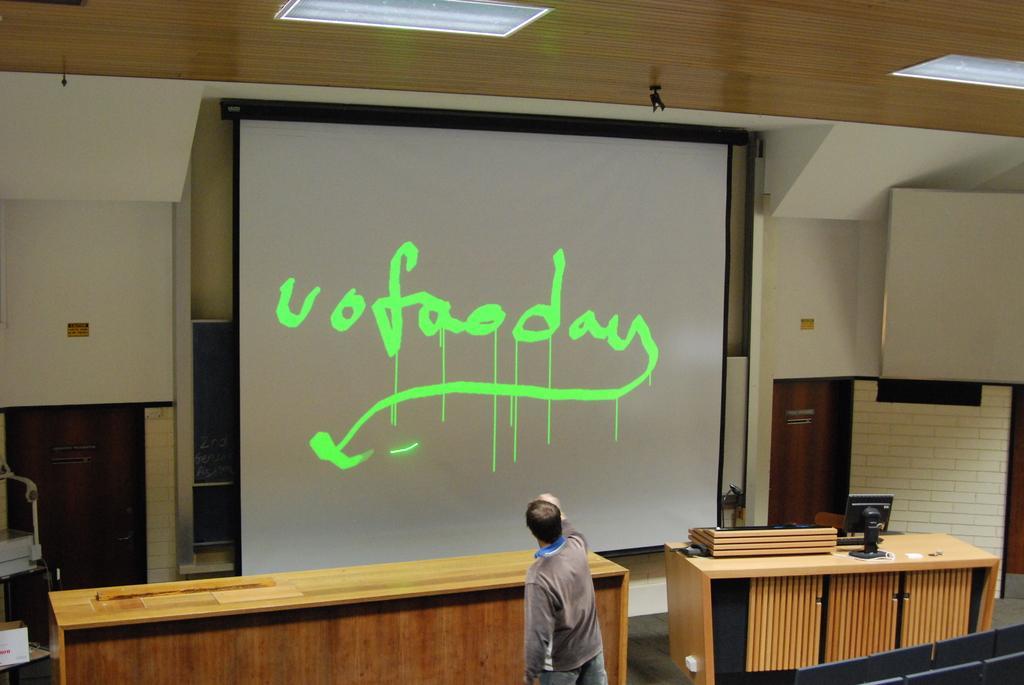Can you describe this image briefly? In front of the picture, the man in brown jacket and blue jeans is standing and watching the projector screen which is placed opposite to him and on that projector screen, we see blue text. In front of him, we see a table and on the right side of the picture, we see another table on which monitor is placed. On the top of a picture, we see the ceiling of that room. 